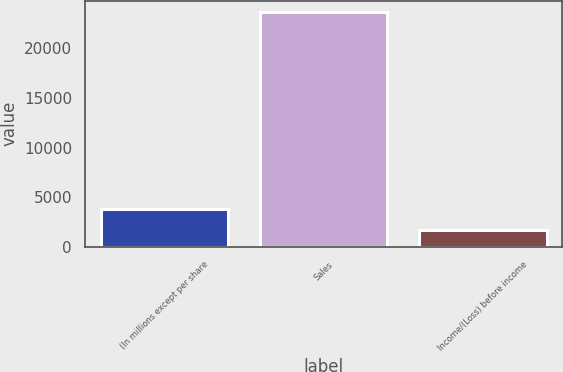<chart> <loc_0><loc_0><loc_500><loc_500><bar_chart><fcel>(In millions except per share<fcel>Sales<fcel>Income/(Loss) before income<nl><fcel>3842.4<fcel>23610<fcel>1646<nl></chart> 